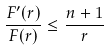<formula> <loc_0><loc_0><loc_500><loc_500>\frac { F ^ { \prime } ( r ) } { F ( r ) } \leq \frac { n + 1 } { r }</formula> 